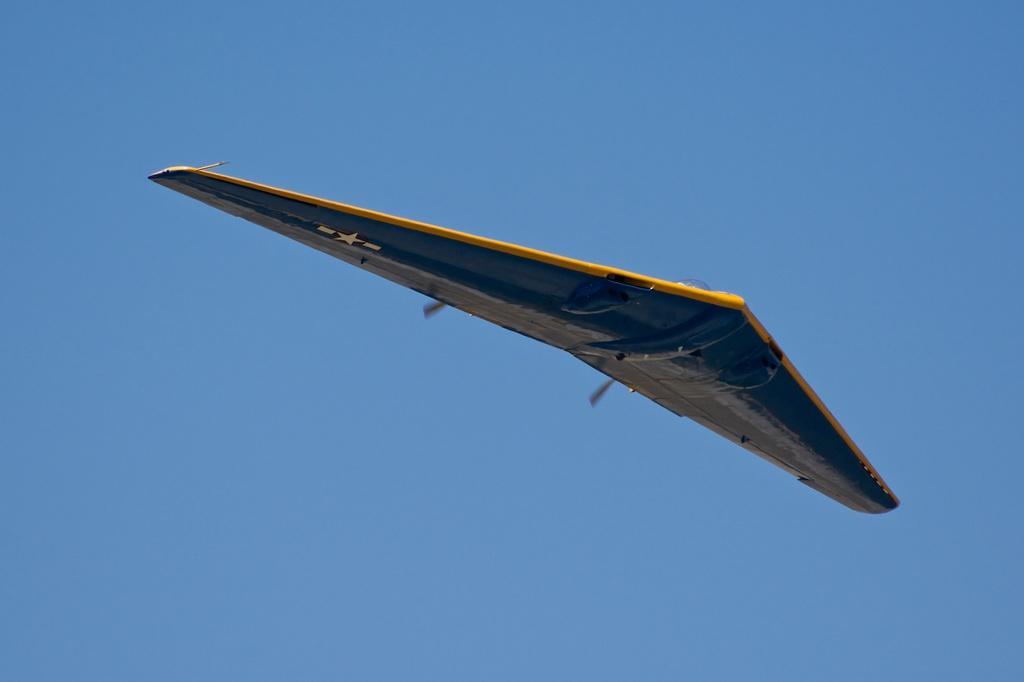Please provide a concise description of this image. In the image we can see a flying jet in the air and a blue sky. 